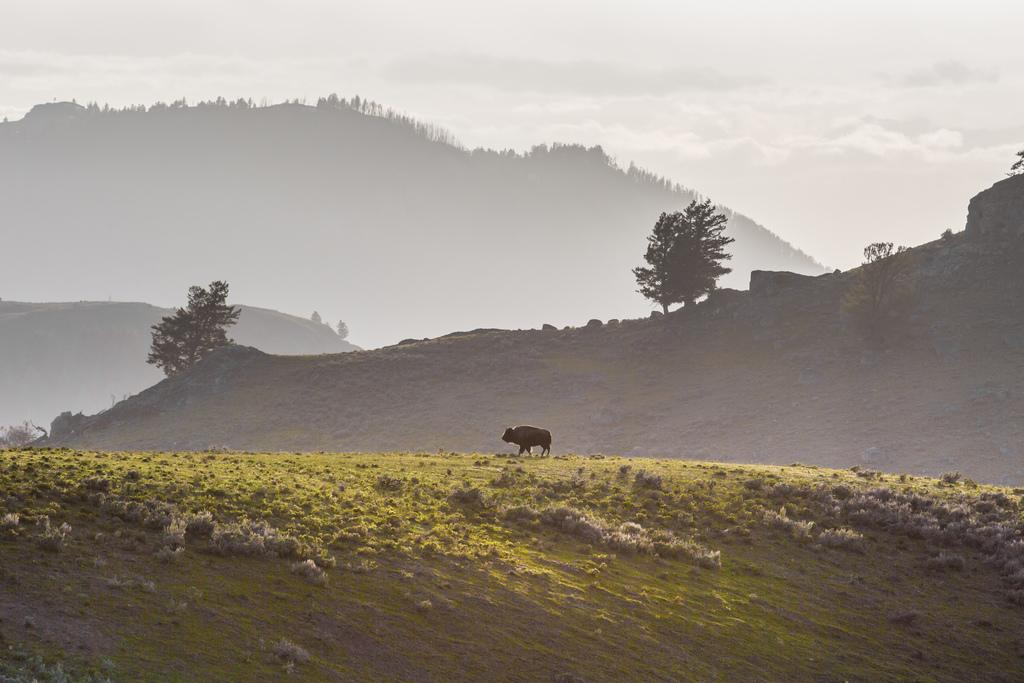What is the main subject of the image? There is an animal in the image. What is the animal doing in the image? The animal is walking. What can be seen in the background of the image? There are trees, mountains, and a cloudy sky in the background of the image. How many pears are on the chessboard in the image? There are no pears or chessboards present in the image. How many rabbits are visible in the image? There are no rabbits visible in the image; the main subject is an animal, but its specific type is not mentioned. 